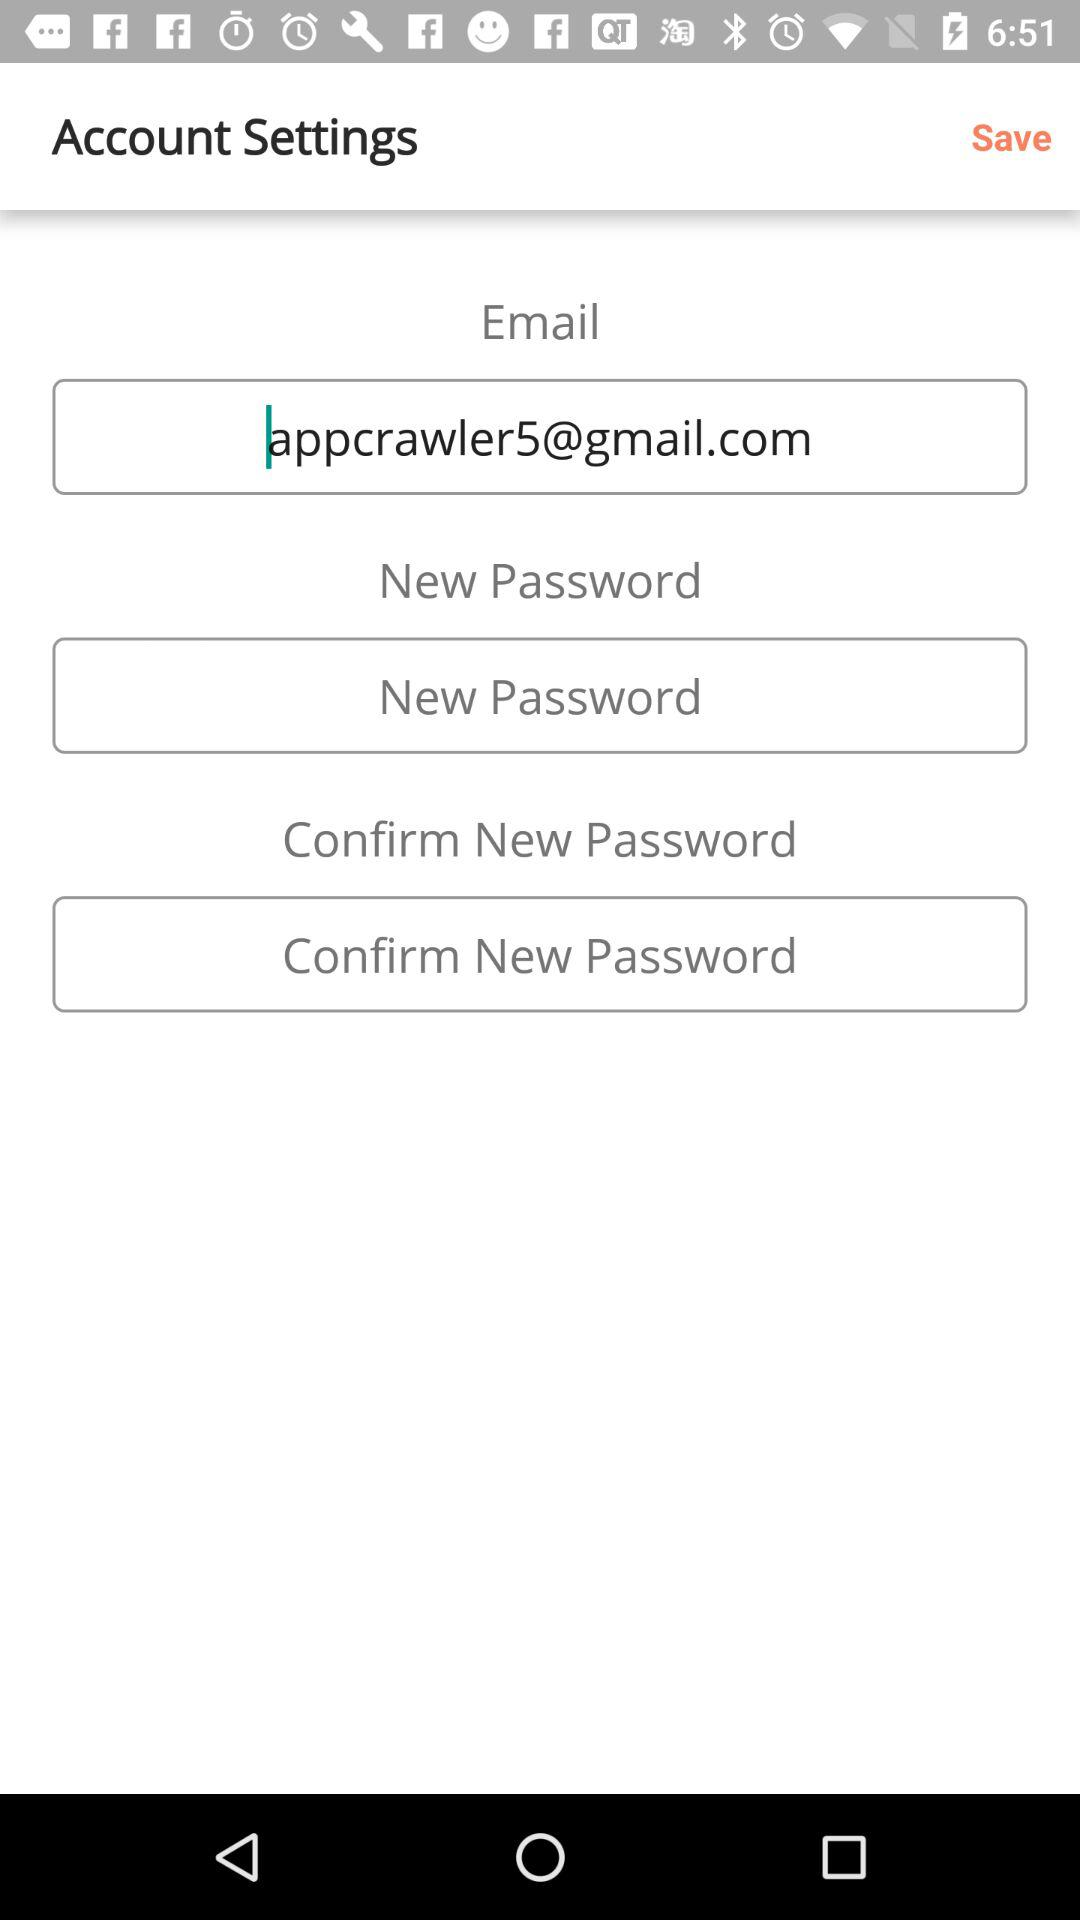What is the email address? The email address is appcrawler5@gmail.com. 